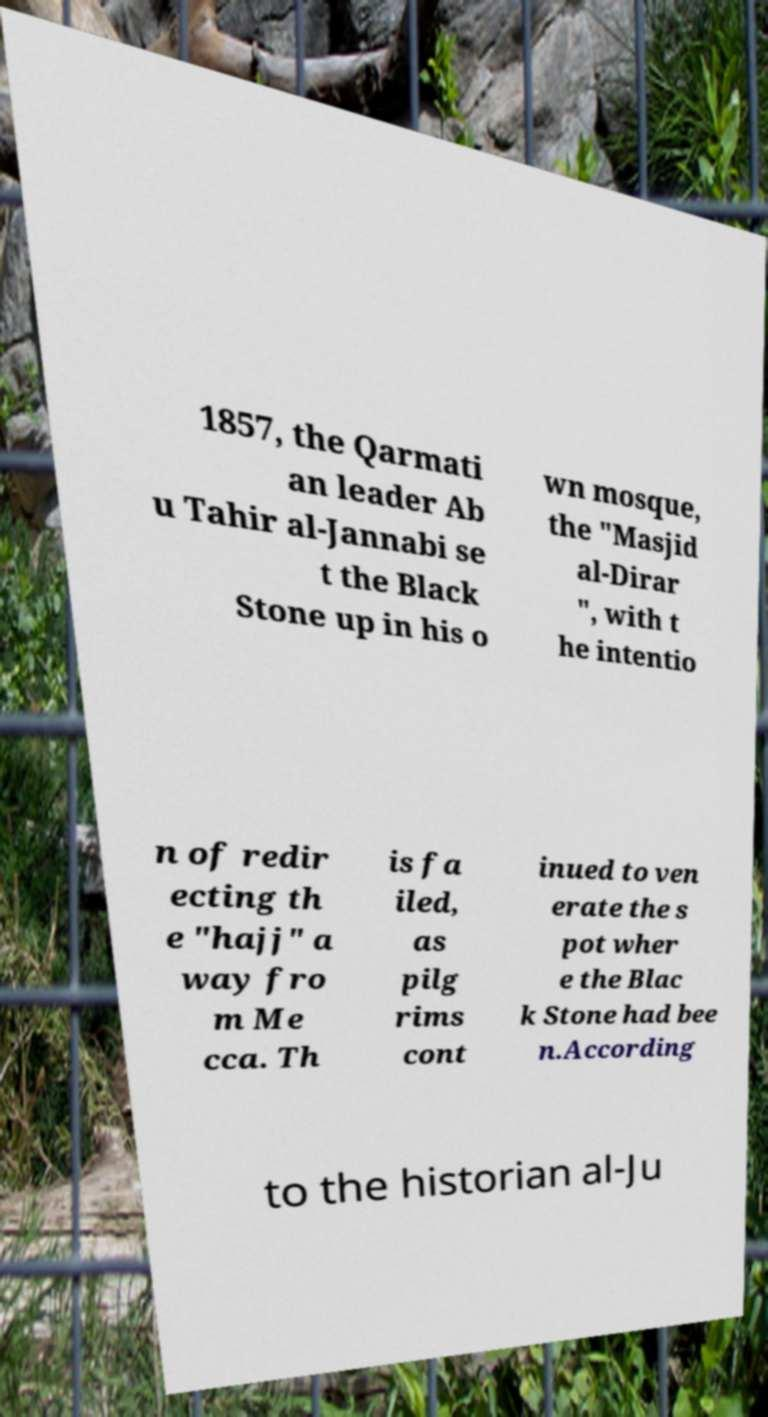Can you accurately transcribe the text from the provided image for me? 1857, the Qarmati an leader Ab u Tahir al-Jannabi se t the Black Stone up in his o wn mosque, the "Masjid al-Dirar ", with t he intentio n of redir ecting th e "hajj" a way fro m Me cca. Th is fa iled, as pilg rims cont inued to ven erate the s pot wher e the Blac k Stone had bee n.According to the historian al-Ju 